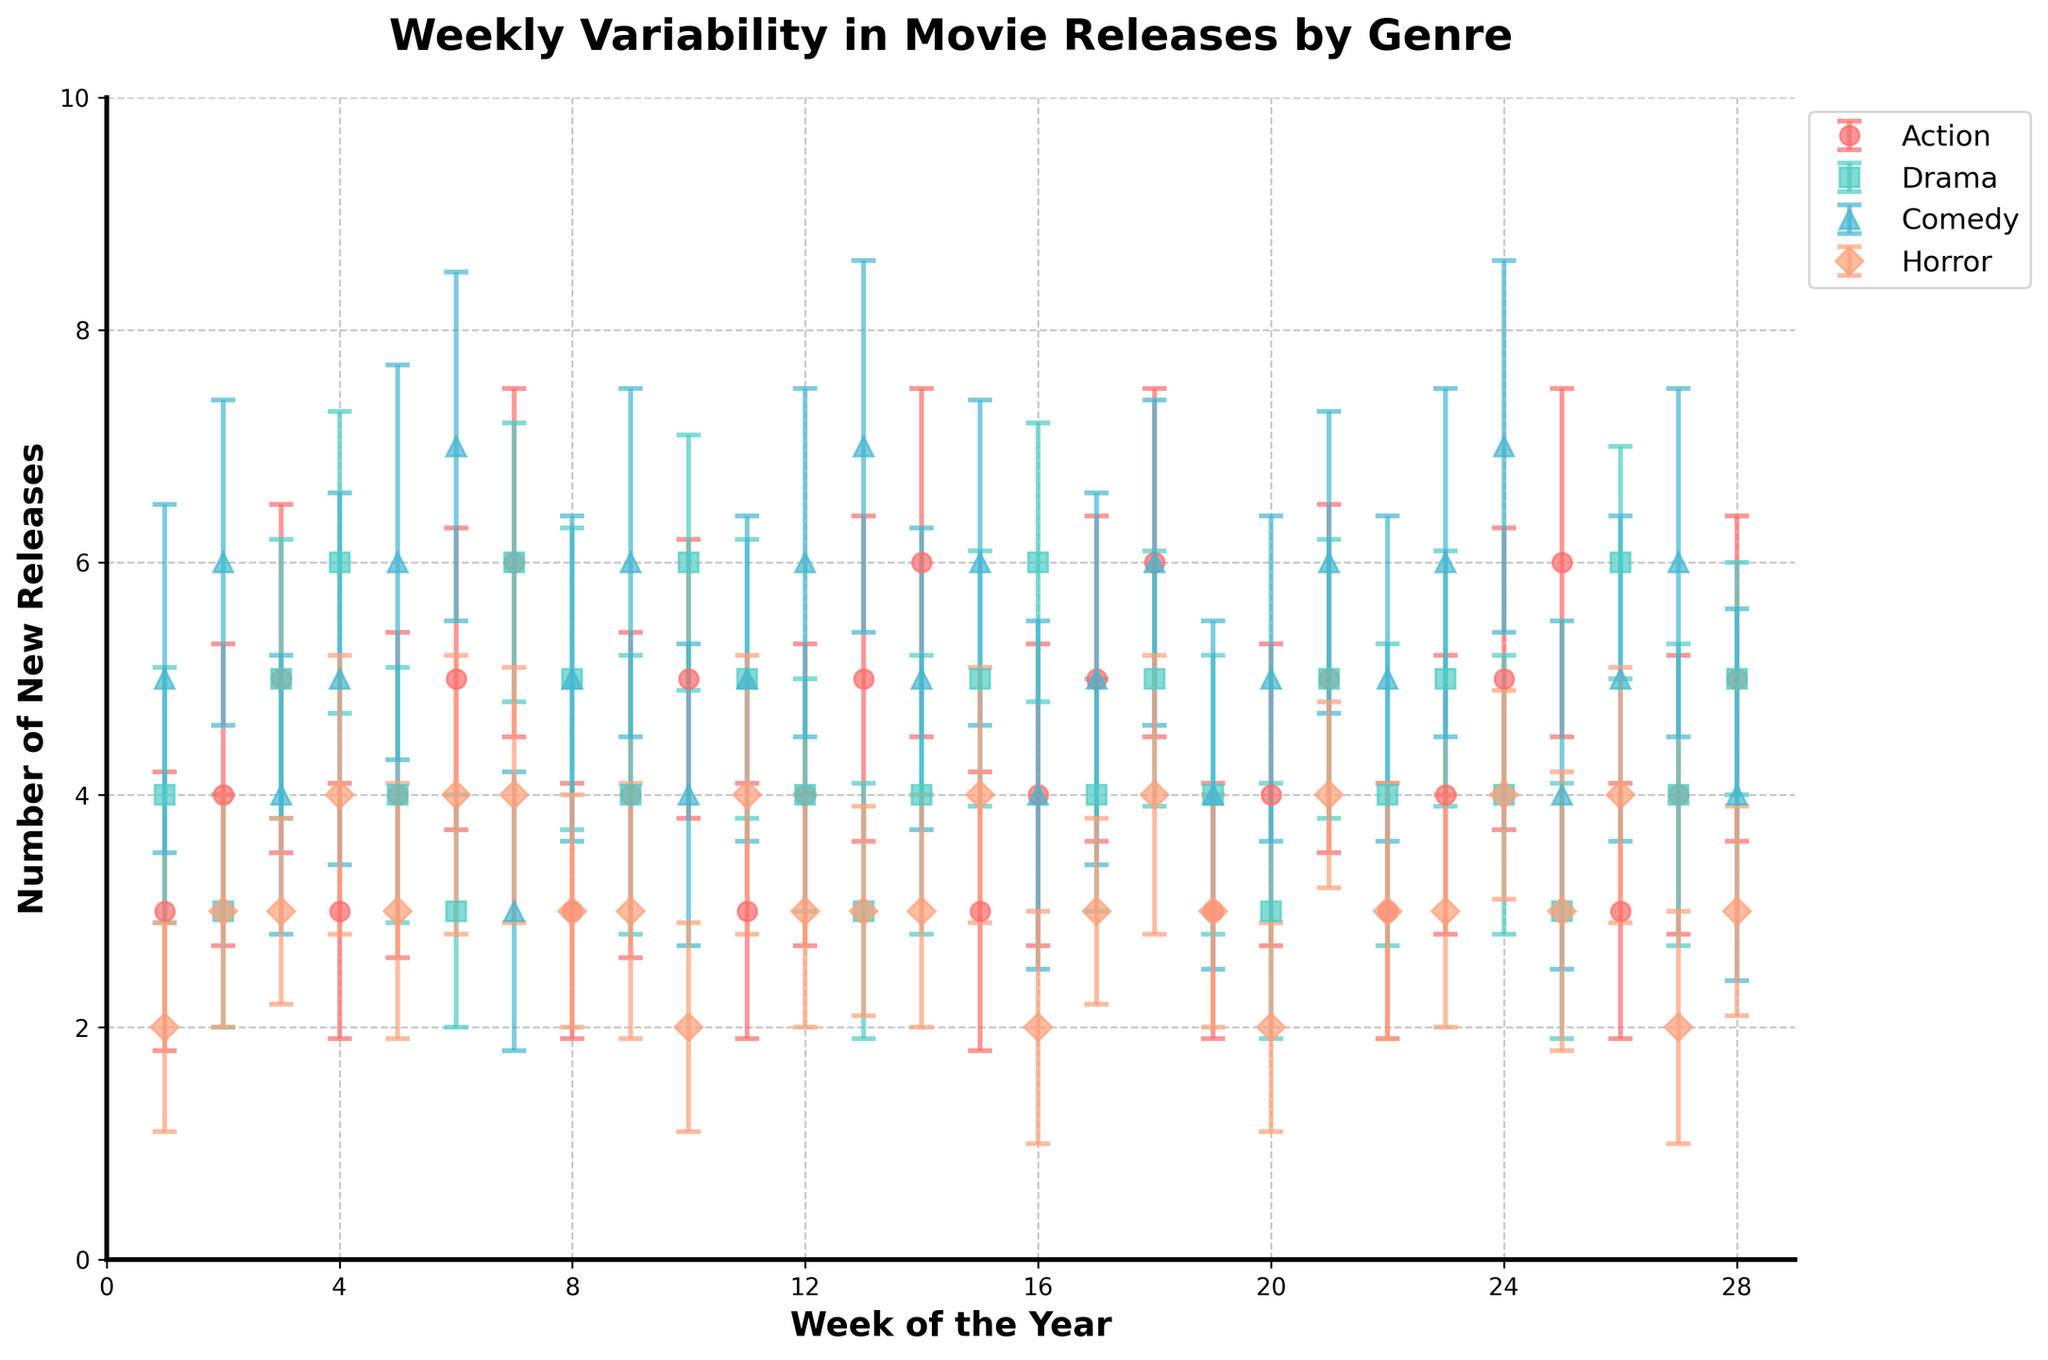What's the title of the plot? The title of the plot is typically located at the top of the figure. Observing the top, we can see the text "Weekly Variability in Movie Releases by Genre".
Answer: Weekly Variability in Movie Releases by Genre How many genres are represented in the plot? We can look at the legend on the right side of the figure which lists all the genres. The genres mentioned are Action, Drama, Comedy, and Horror.
Answer: 4 Which genre has the highest average number of releases in week 1? We need to look for week 1 on the x-axis, and then compare the markers (and their y-values) for different genres in that week. The Comedy genre appears to have the highest mean value.
Answer: Comedy What is the mean number of new Action releases in week 6 and its standard deviation? Locate week 6 on the x-axis, then find the marker for Action (using the legend to identify its color and shape). We observe the mean value at week 6 and refer to the plot legend to recognize the error bar lengths indicating deviation. The mean is 5 and the standard deviation is 1.3, as shown by the error bars.
Answer: 5, 1.3 During which weeks is the mean number of Drama releases higher than that of Horror releases? To answer this, we need to compare the Drama and Horror markers (in blue and orange, respectively) for each week. Weeks 4, 16, and 25 have the Drama genre above Horror.
Answer: Weeks 4, 16, 25 What week does Drama have its highest mean number of releases and what is that number? Find the Drama markers and identify the highest point on the y-axis to determine the week. Week 4 shows the highest Drama releases, with a mean number of 6.
Answer: Week 4, 6 Calculate the total mean of Comedy releases over weeks 1 to 4. Add the mean values of Comedy from weeks 1 to 4 and divide by the number of weeks (4). The values are 5, 6, 4, and 5, giving us a sum of 20. The mean is thus 20/4 = 5.
Answer: 5 Which genre appears to have the most consistent number of new releases, based on the error bars in general? To determine consistency, look for the genre with the shortest error bars overall. Horror shows the smallest error bars, indicating less variability and more consistency.
Answer: Horror Is there any week where Action and Horror releases are equal in mean value? Scan through the weeks checking when the markers for Action and Horror align on the y-axis. Both genres have equal means in week 1 with 3 releases.
Answer: Week 1 What is the trend in the mean number of Action releases from week 1 to week 7? Observe the Action markers from week 1 to week 7, noting if the genre's number of releases increases or decreases. The trend shows a gradual increase in Action releases from 3 in week 1 to 6 in week 7.
Answer: Increasing 